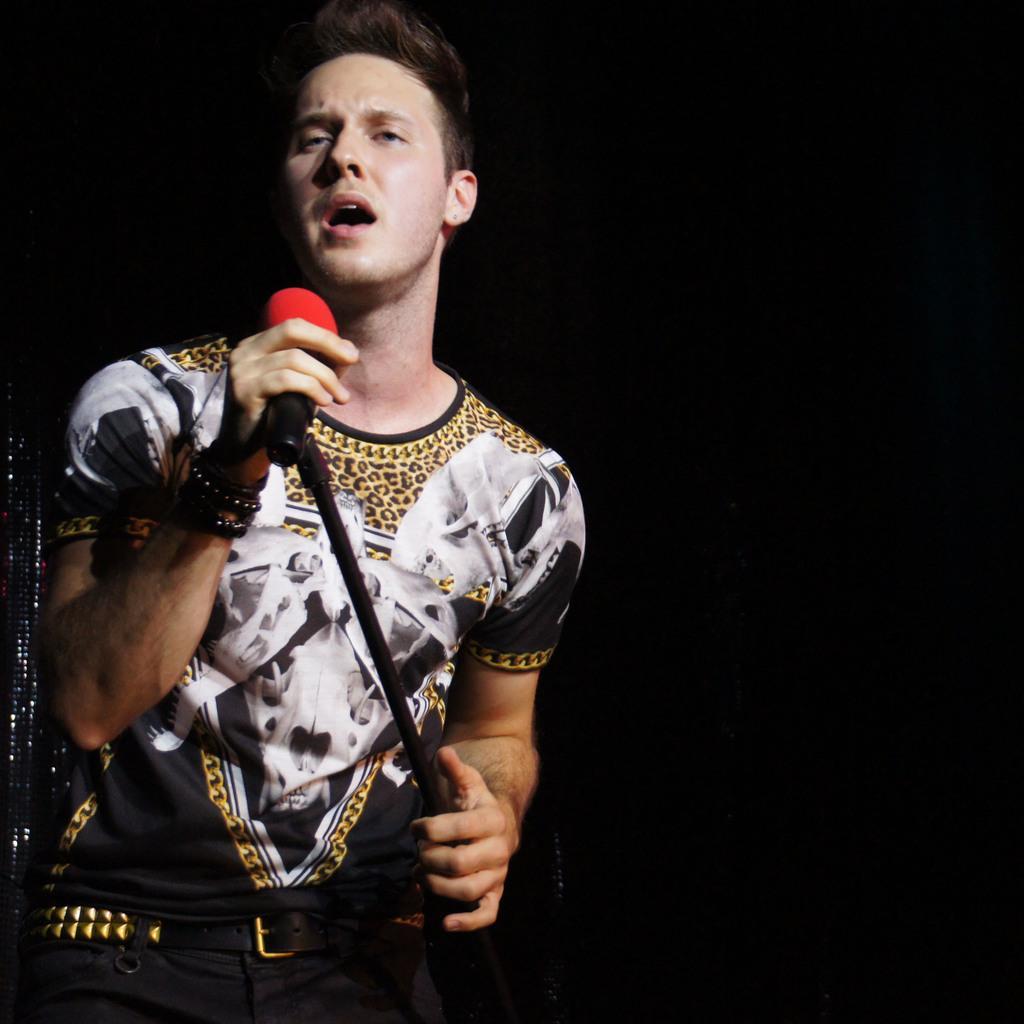Describe this image in one or two sentences. In the left, a person is standing and singing a song in mike. The background is dark in color. This image is taken on the stage during night time. 